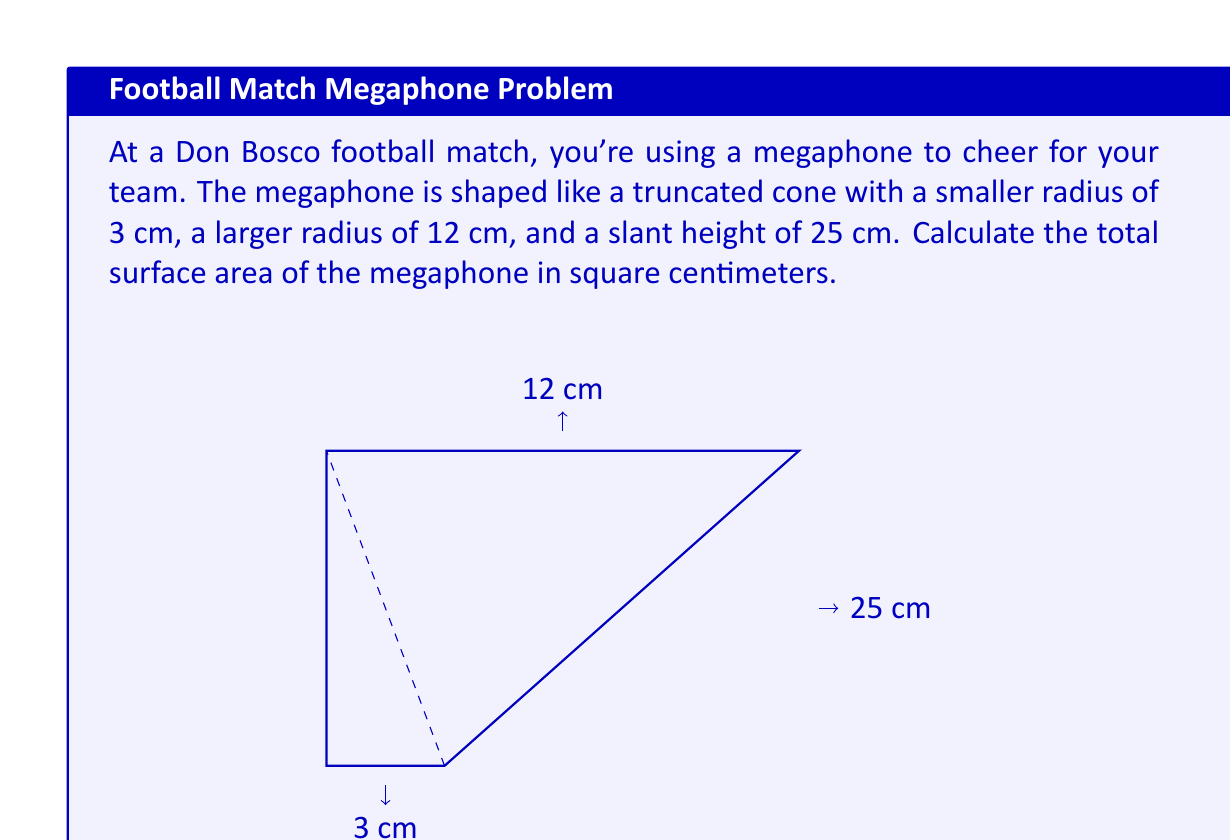Show me your answer to this math problem. To find the surface area of a truncated cone, we need to calculate the area of the circular base, the circular top, and the lateral surface area. Let's break it down step by step:

1) Area of the circular base:
   $A_1 = \pi r_1^2 = \pi (3\text{ cm})^2 = 9\pi\text{ cm}^2$

2) Area of the circular top:
   $A_2 = \pi r_2^2 = \pi (12\text{ cm})^2 = 144\pi\text{ cm}^2$

3) Lateral surface area:
   The formula for the lateral surface area of a truncated cone is:
   $A_L = \pi(r_1 + r_2)s$
   where $s$ is the slant height.

   $A_L = \pi(3\text{ cm} + 12\text{ cm})(25\text{ cm}) = 375\pi\text{ cm}^2$

4) Total surface area:
   $A_{total} = A_1 + A_2 + A_L$
   $A_{total} = 9\pi\text{ cm}^2 + 144\pi\text{ cm}^2 + 375\pi\text{ cm}^2$
   $A_{total} = 528\pi\text{ cm}^2$

5) To get the final answer in square centimeters:
   $A_{total} = 528\pi\text{ cm}^2 \approx 1658.76\text{ cm}^2$
Answer: The total surface area of the megaphone is approximately $1658.76\text{ cm}^2$. 